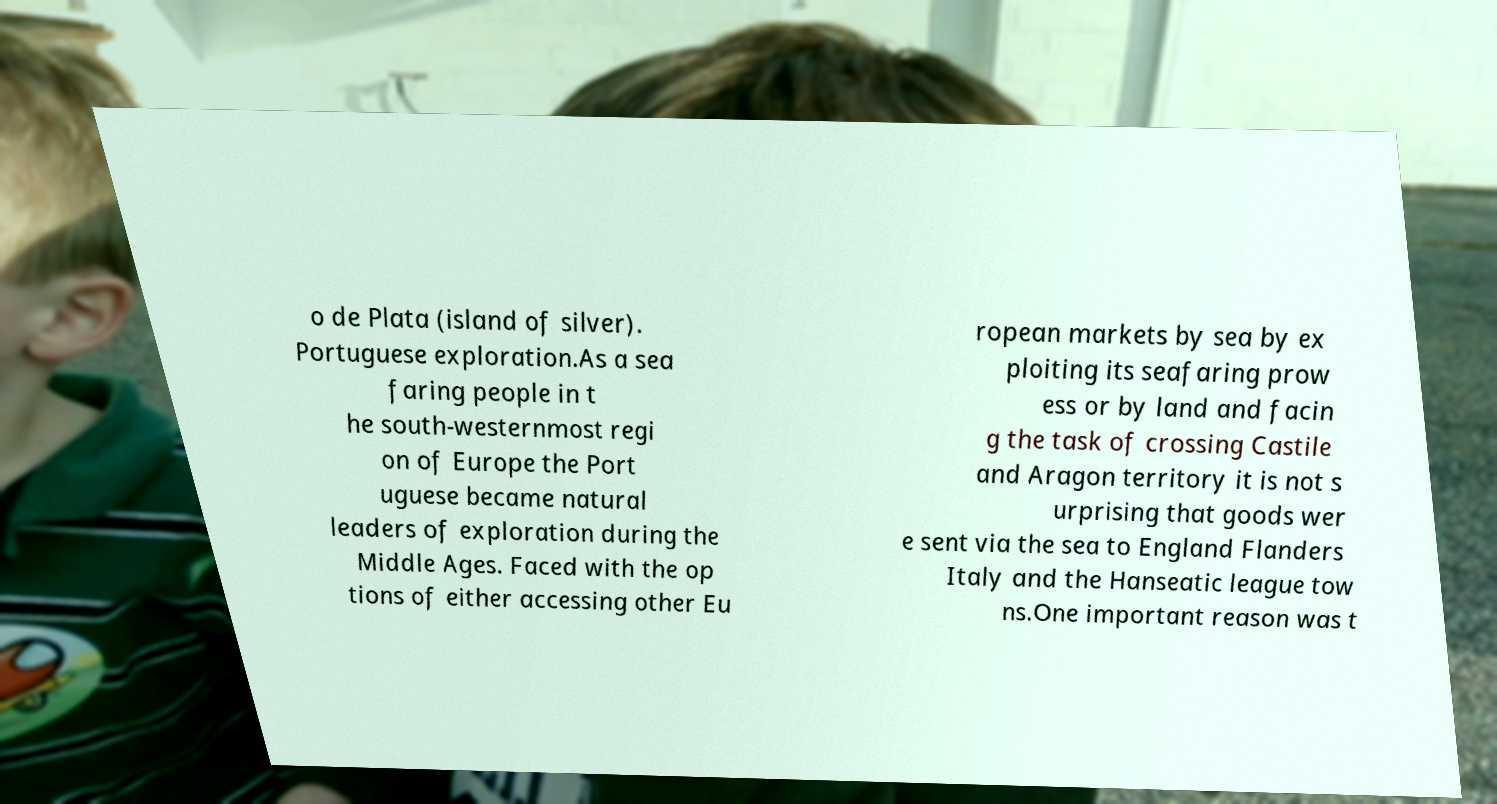Could you assist in decoding the text presented in this image and type it out clearly? o de Plata (island of silver). Portuguese exploration.As a sea faring people in t he south-westernmost regi on of Europe the Port uguese became natural leaders of exploration during the Middle Ages. Faced with the op tions of either accessing other Eu ropean markets by sea by ex ploiting its seafaring prow ess or by land and facin g the task of crossing Castile and Aragon territory it is not s urprising that goods wer e sent via the sea to England Flanders Italy and the Hanseatic league tow ns.One important reason was t 